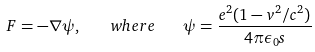<formula> <loc_0><loc_0><loc_500><loc_500>F = - \nabla \psi , \quad w h e r e \quad \psi = \frac { e ^ { 2 } ( 1 - v ^ { 2 } / c ^ { 2 } ) } { 4 \pi \epsilon _ { 0 } s }</formula> 